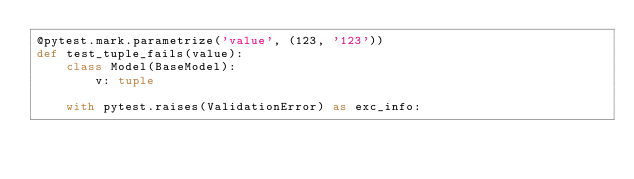Convert code to text. <code><loc_0><loc_0><loc_500><loc_500><_Python_>@pytest.mark.parametrize('value', (123, '123'))
def test_tuple_fails(value):
    class Model(BaseModel):
        v: tuple

    with pytest.raises(ValidationError) as exc_info:</code> 